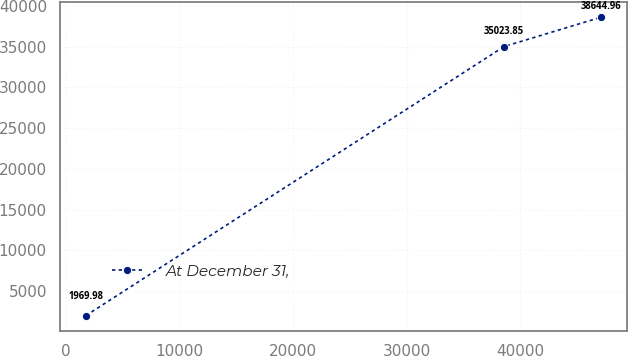Convert chart to OTSL. <chart><loc_0><loc_0><loc_500><loc_500><line_chart><ecel><fcel>At December 31,<nl><fcel>1756.08<fcel>1969.98<nl><fcel>38564.4<fcel>35023.8<nl><fcel>47144.7<fcel>38645<nl></chart> 